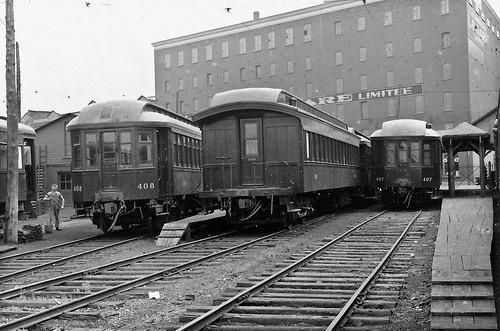How many tracks are there?
Give a very brief answer. 3. How many people are in this picture?
Give a very brief answer. 1. How many windows are on the back of the middle train?
Give a very brief answer. 1. 